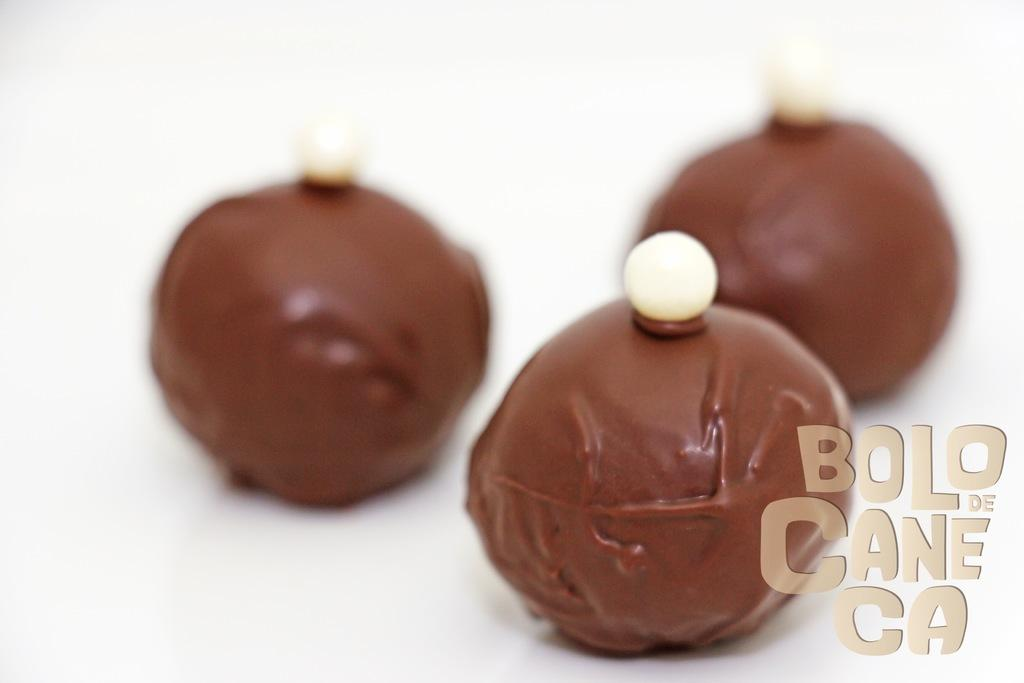What is depicted on the poster in the image? The poster contains chocolate balls. Can you describe any additional features of the image? There is a watermark at the bottom of the image. How many baseballs are shown in the image? There are no baseballs present in the image; it features a poster with chocolate balls and a watermark. What type of mitten is being used to order the chocolate balls in the image? There is no mitten or ordering process depicted in the image. 